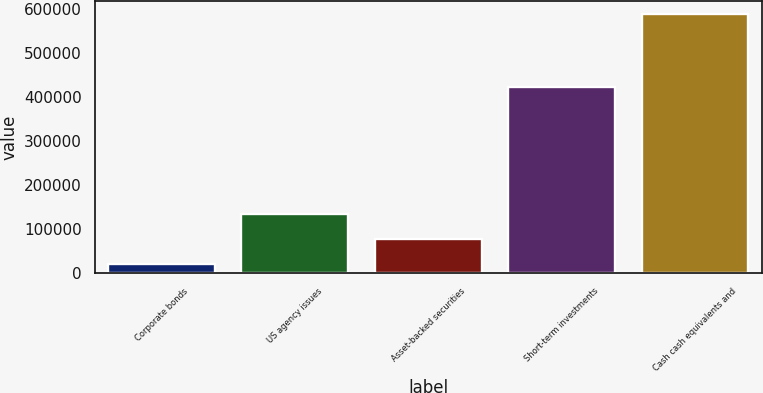Convert chart. <chart><loc_0><loc_0><loc_500><loc_500><bar_chart><fcel>Corporate bonds<fcel>US agency issues<fcel>Asset-backed securities<fcel>Short-term investments<fcel>Cash cash equivalents and<nl><fcel>21047<fcel>134348<fcel>77697.5<fcel>422432<fcel>587552<nl></chart> 